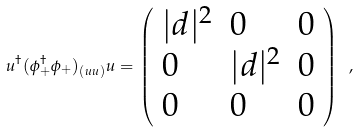<formula> <loc_0><loc_0><loc_500><loc_500>u ^ { \dagger } ( \phi _ { + } ^ { \dagger } \phi _ { + } ) _ { ( u u ) } u = \left ( \begin{array} { l l l } { { | { d } | ^ { 2 } } } & { 0 } & { 0 } \\ { 0 } & { { | { d } | ^ { 2 } } } & { 0 } \\ { 0 } & { 0 } & { 0 } \end{array} \right ) \ ,</formula> 